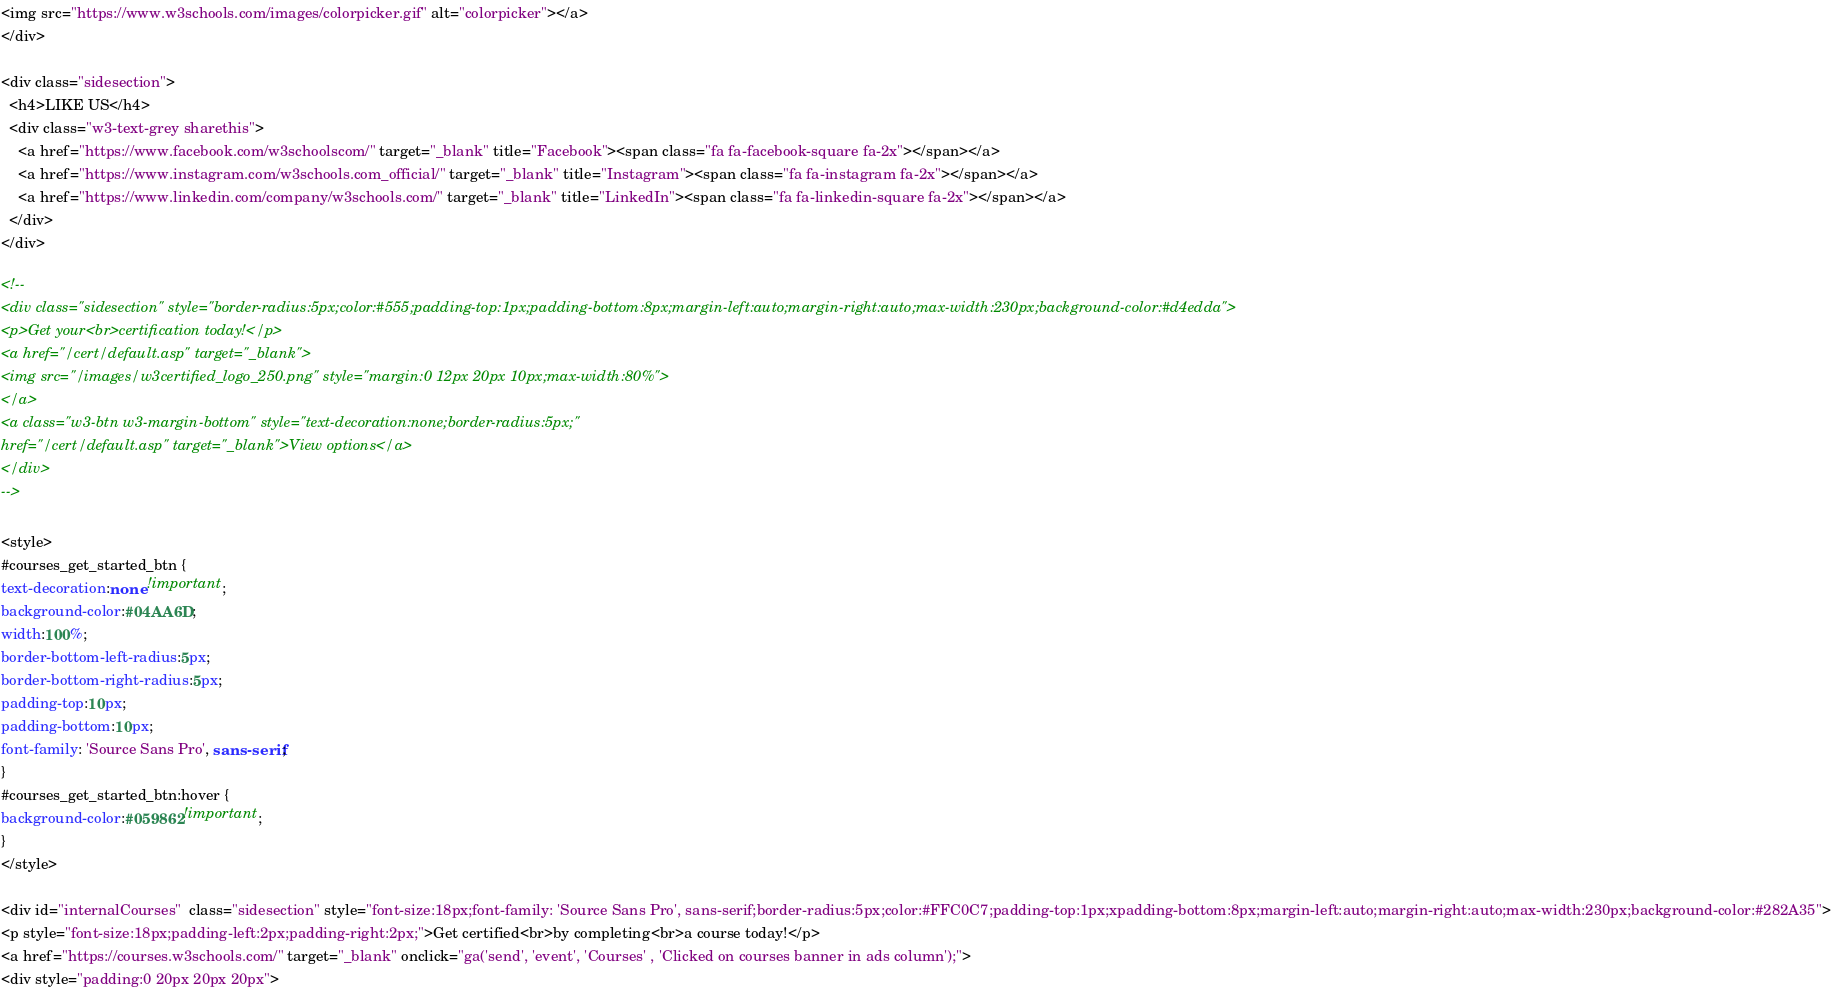<code> <loc_0><loc_0><loc_500><loc_500><_HTML_><img src="https://www.w3schools.com/images/colorpicker.gif" alt="colorpicker"></a>
</div>

<div class="sidesection">
  <h4>LIKE US</h4>
  <div class="w3-text-grey sharethis">
    <a href="https://www.facebook.com/w3schoolscom/" target="_blank" title="Facebook"><span class="fa fa-facebook-square fa-2x"></span></a>
    <a href="https://www.instagram.com/w3schools.com_official/" target="_blank" title="Instagram"><span class="fa fa-instagram fa-2x"></span></a>
    <a href="https://www.linkedin.com/company/w3schools.com/" target="_blank" title="LinkedIn"><span class="fa fa-linkedin-square fa-2x"></span></a>
  </div>
</div>

<!--
<div class="sidesection" style="border-radius:5px;color:#555;padding-top:1px;padding-bottom:8px;margin-left:auto;margin-right:auto;max-width:230px;background-color:#d4edda">
<p>Get your<br>certification today!</p>
<a href="/cert/default.asp" target="_blank">
<img src="/images/w3certified_logo_250.png" style="margin:0 12px 20px 10px;max-width:80%">
</a>
<a class="w3-btn w3-margin-bottom" style="text-decoration:none;border-radius:5px;"
href="/cert/default.asp" target="_blank">View options</a>
</div>
-->

<style>
#courses_get_started_btn {
text-decoration:none !important;
background-color:#04AA6D;
width:100%;
border-bottom-left-radius:5px;
border-bottom-right-radius:5px;
padding-top:10px;
padding-bottom:10px;
font-family: 'Source Sans Pro', sans-serif;
}
#courses_get_started_btn:hover {
background-color:#059862!important;
}
</style>

<div id="internalCourses"  class="sidesection" style="font-size:18px;font-family: 'Source Sans Pro', sans-serif;border-radius:5px;color:#FFC0C7;padding-top:1px;xpadding-bottom:8px;margin-left:auto;margin-right:auto;max-width:230px;background-color:#282A35">
<p style="font-size:18px;padding-left:2px;padding-right:2px;">Get certified<br>by completing<br>a course today!</p>
<a href="https://courses.w3schools.com/" target="_blank" onclick="ga('send', 'event', 'Courses' , 'Clicked on courses banner in ads column');">
<div style="padding:0 20px 20px 20px"></code> 